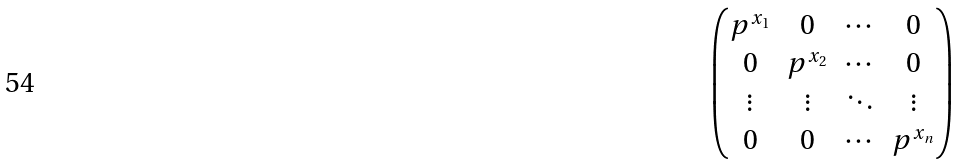<formula> <loc_0><loc_0><loc_500><loc_500>\begin{pmatrix} p ^ { x _ { 1 } } & 0 & \cdots & 0 \\ 0 & p ^ { x _ { 2 } } & \cdots & 0 \\ \vdots & \vdots & \ddots & \vdots \\ 0 & 0 & \cdots & p ^ { x _ { n } } \end{pmatrix}</formula> 